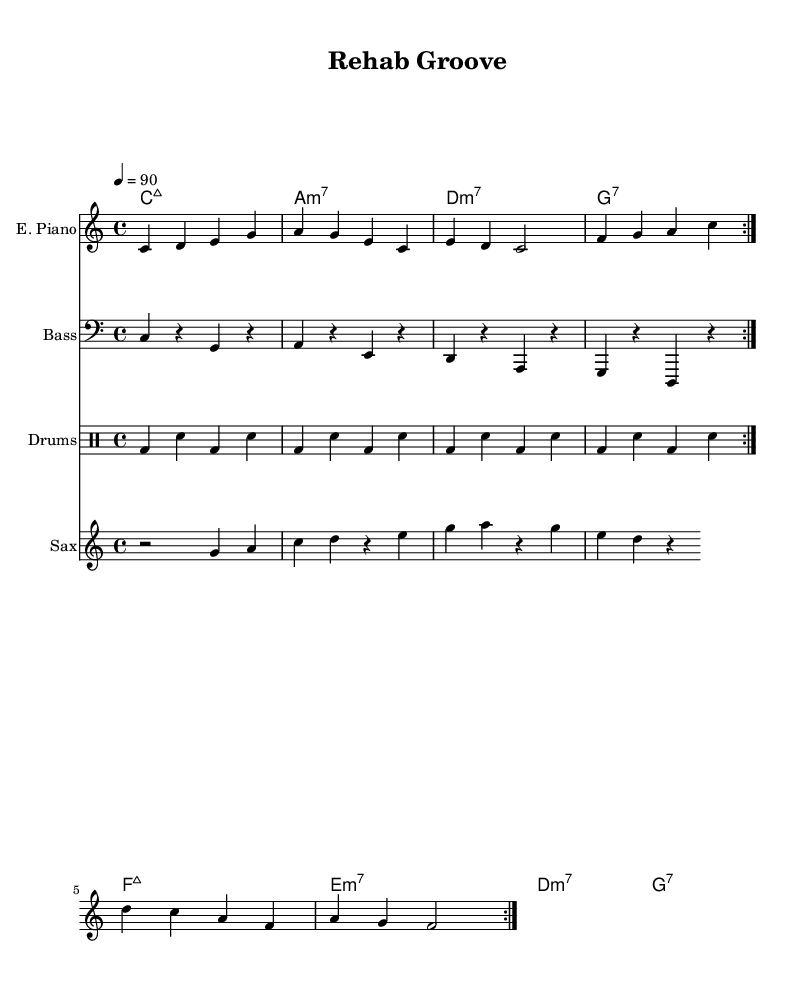What is the key signature of this music? The key signature is C major, which has no sharps or flats.
Answer: C major What is the time signature of this piece? The time signature is indicated at the beginning, showing four beats per measure.
Answer: 4/4 What is the tempo marking in this sheet music? The tempo marking specifies a speed of quarter note = 90 beats per minute.
Answer: 90 How many times is the electric piano's section repeated? The repeat sign indicates that the section should be played two times.
Answer: 2 What is the chord used for the first measure? The first measure features a C major seventh chord, which is indicated above the staff with its chord symbol.
Answer: C:maj7 How do the drum patterns contribute to the funk style? The drum pattern includes a syncopated rhythm with bass and snare interactions, typical of funk, which provides a groove and drives the piece forward.
Answer: Syncopation What is the overall mood conveyed by this piece? The combination of smooth melodies from the electric piano and saxophone, along with the laid-back rhythm section, creates a relaxed and soothing atmosphere, suitable for rehabilitation.
Answer: Relaxation 